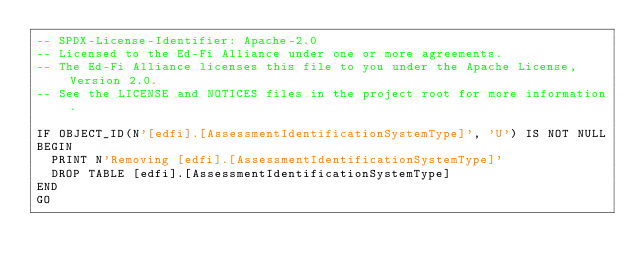Convert code to text. <code><loc_0><loc_0><loc_500><loc_500><_SQL_>-- SPDX-License-Identifier: Apache-2.0
-- Licensed to the Ed-Fi Alliance under one or more agreements.
-- The Ed-Fi Alliance licenses this file to you under the Apache License, Version 2.0.
-- See the LICENSE and NOTICES files in the project root for more information.

IF OBJECT_ID(N'[edfi].[AssessmentIdentificationSystemType]', 'U') IS NOT NULL
BEGIN
	PRINT N'Removing [edfi].[AssessmentIdentificationSystemType]'
	DROP TABLE [edfi].[AssessmentIdentificationSystemType]
END
GO

</code> 